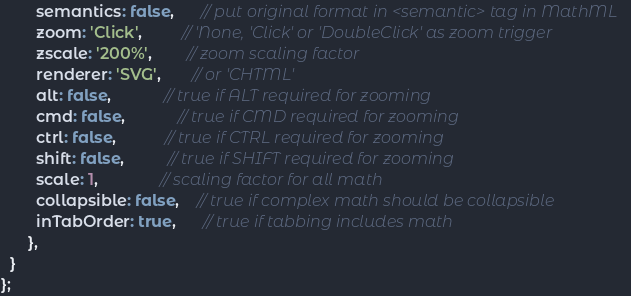<code> <loc_0><loc_0><loc_500><loc_500><_JavaScript_>        semantics: false,      // put original format in <semantic> tag in MathML
        zoom: 'Click',         // 'None, 'Click' or 'DoubleClick' as zoom trigger
        zscale: '200%',        // zoom scaling factor
        renderer: 'SVG',       // or 'CHTML'
        alt: false,            // true if ALT required for zooming
        cmd: false,            // true if CMD required for zooming
        ctrl: false,           // true if CTRL required for zooming
        shift: false,          // true if SHIFT required for zooming
        scale: 1,              // scaling factor for all math
        collapsible: false,    // true if complex math should be collapsible
        inTabOrder: true,      // true if tabbing includes math
      },
  }
};
</code> 